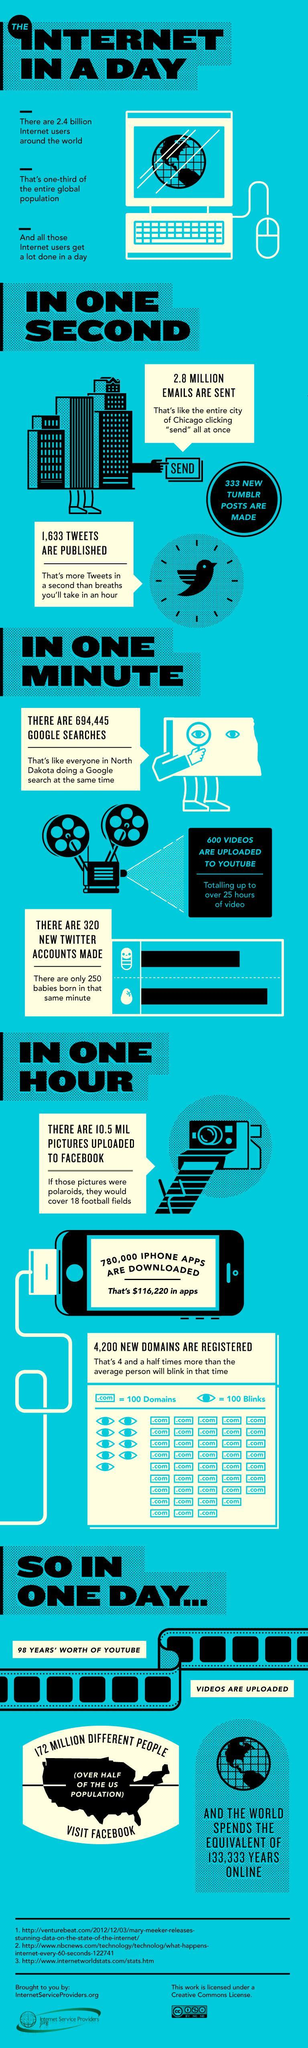How many sources are listed?
Answer the question with a short phrase. 3 What fraction of population uses internet around the world? one-third 